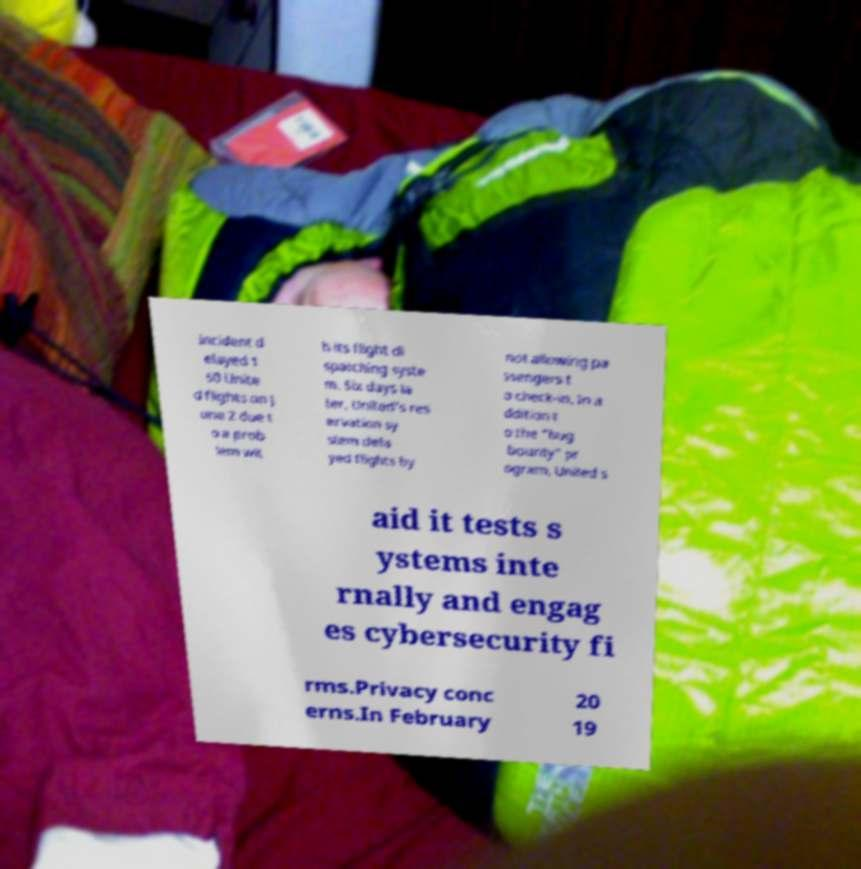I need the written content from this picture converted into text. Can you do that? incident d elayed 1 50 Unite d flights on J une 2 due t o a prob lem wit h its flight di spatching syste m. Six days la ter, United's res ervation sy stem dela yed flights by not allowing pa ssengers t o check-in. In a ddition t o the "bug bounty" pr ogram, United s aid it tests s ystems inte rnally and engag es cybersecurity fi rms.Privacy conc erns.In February 20 19 